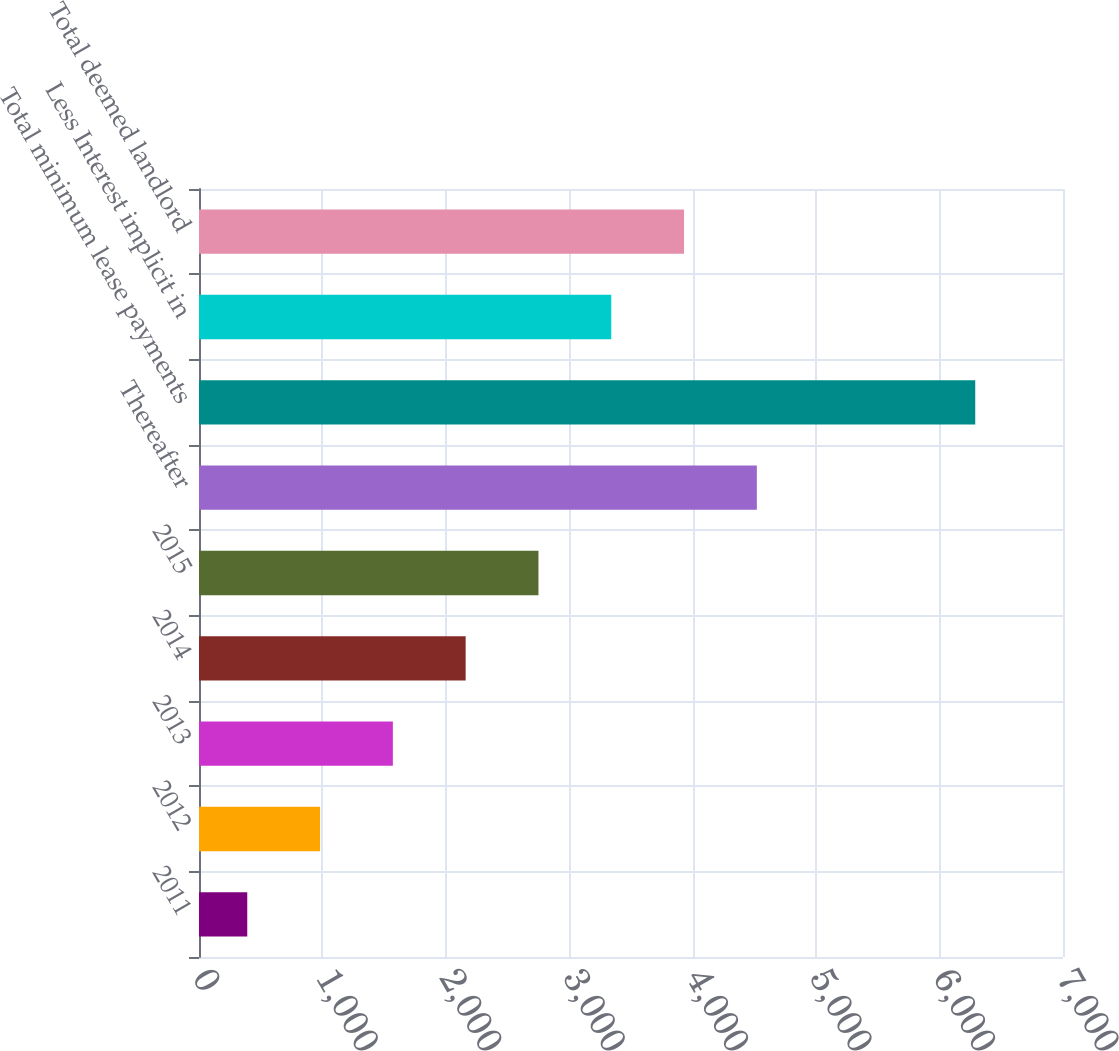Convert chart. <chart><loc_0><loc_0><loc_500><loc_500><bar_chart><fcel>2011<fcel>2012<fcel>2013<fcel>2014<fcel>2015<fcel>Thereafter<fcel>Total minimum lease payments<fcel>Less Interest implicit in<fcel>Total deemed landlord<nl><fcel>391<fcel>980.8<fcel>1570.6<fcel>2160.4<fcel>2750.2<fcel>4519.6<fcel>6289<fcel>3340<fcel>3929.8<nl></chart> 